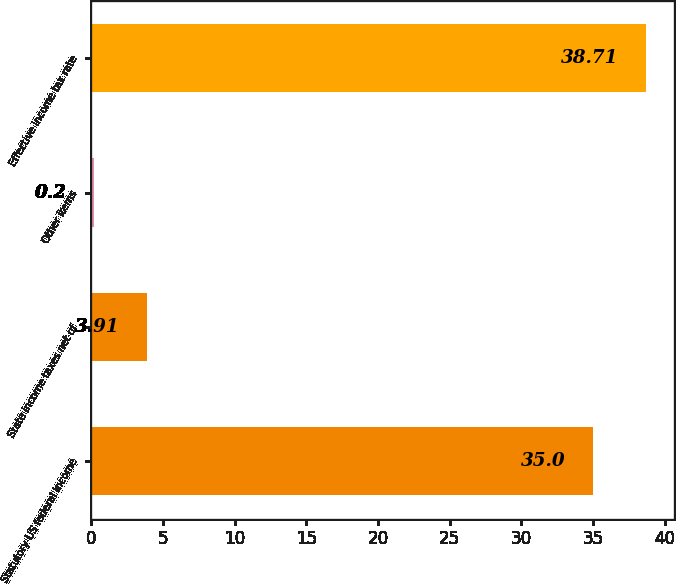Convert chart to OTSL. <chart><loc_0><loc_0><loc_500><loc_500><bar_chart><fcel>Statutory US federal income<fcel>State income taxes net of<fcel>Other items<fcel>Effective income tax rate<nl><fcel>35<fcel>3.91<fcel>0.2<fcel>38.71<nl></chart> 